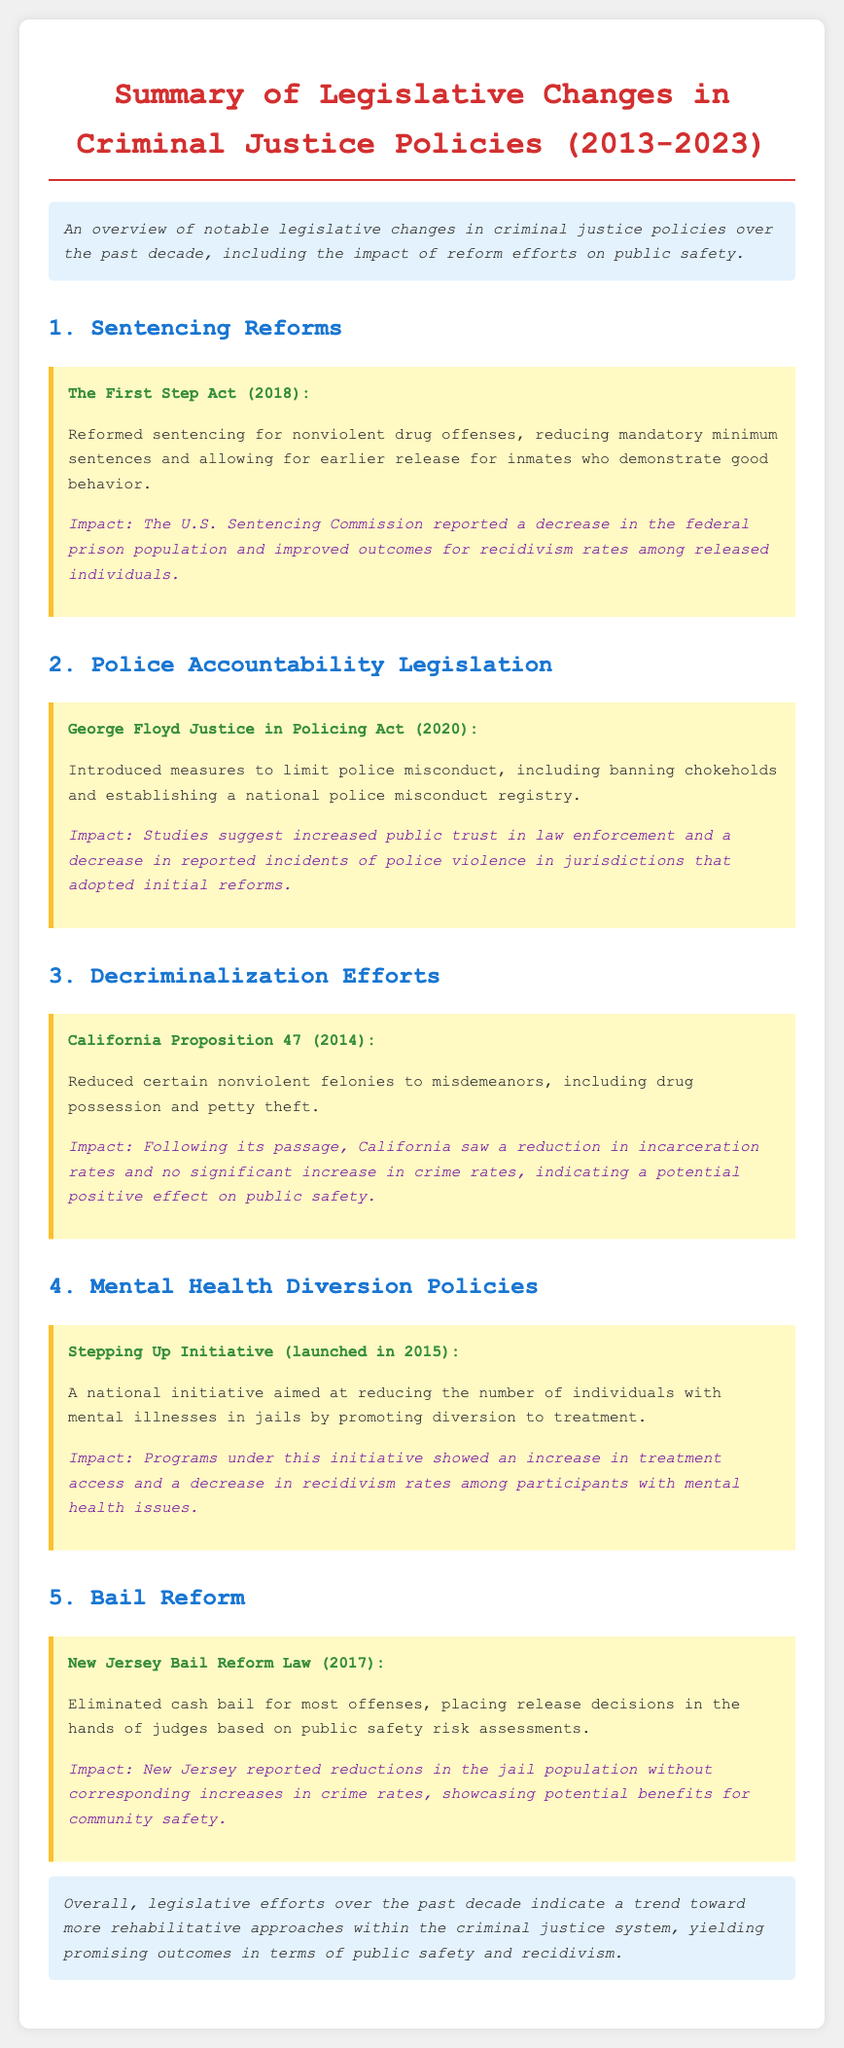What is the title of the document? The title of the document is mentioned at the beginning section, which summarizes the topic covered, namely legislative changes in criminal justice policies.
Answer: Summary of Legislative Changes in Criminal Justice Policies (2013-2023) What year was the First Step Act enacted? The document states that the First Step Act was enacted in a specific year, which is 2018.
Answer: 2018 What type of offenses did the First Step Act reform? The document specifies the types of offenses addressed by the First Step Act, indicating it was related to nonviolent drug offenses.
Answer: Nonviolent drug offenses What does the George Floyd Justice in Policing Act address? The document outlines the key focus of the George Floyd Justice in Policing Act, which is police misconduct and accountability measures.
Answer: Police misconduct What was the impact of California Proposition 47 on incarceration rates? The document reports the outcomes following California Proposition 47, specifically mentioning a trend towards reduced incarceration rates.
Answer: Reduction in incarceration rates How does the New Jersey Bail Reform Law determine release decisions? The document explains that the New Jersey Bail Reform Law places release decisions based on certain assessments, specifically public safety risk assessments.
Answer: Public safety risk assessments What initiative promotes diversion to treatment for individuals with mental illnesses? The document mentions a specific initiative aimed at reducing the presence of individuals with mental illnesses in jails, which is the Stepping Up Initiative.
Answer: Stepping Up Initiative What trend has been observed in criminal justice legislative efforts over the past decade? The conclusion of the document details a specific trend regarding the nature of these legislative efforts, hinting towards a rehabilitative approach.
Answer: More rehabilitative approaches What major change did California Proposition 47 implement? The document describes a significant change enacted by California Proposition 47, which was to reduce certain felonies to misdemeanors.
Answer: Reduce certain nonviolent felonies to misdemeanors 